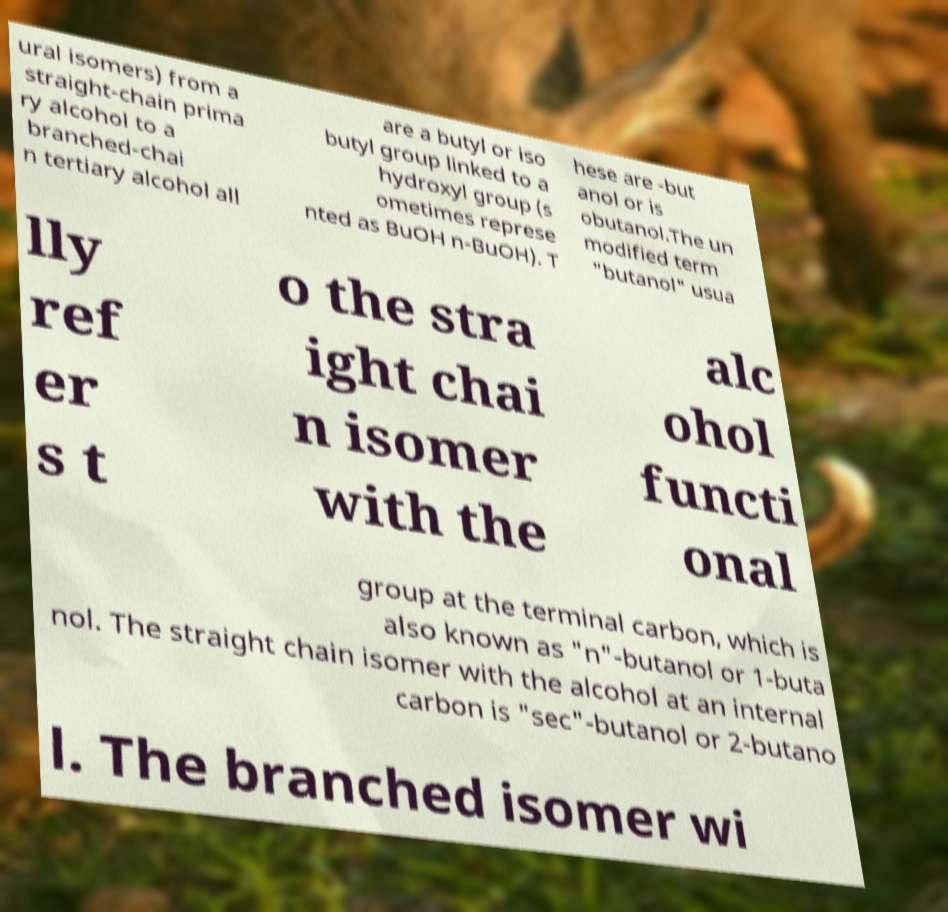Can you accurately transcribe the text from the provided image for me? ural isomers) from a straight-chain prima ry alcohol to a branched-chai n tertiary alcohol all are a butyl or iso butyl group linked to a hydroxyl group (s ometimes represe nted as BuOH n-BuOH). T hese are -but anol or is obutanol.The un modified term "butanol" usua lly ref er s t o the stra ight chai n isomer with the alc ohol functi onal group at the terminal carbon, which is also known as "n"-butanol or 1-buta nol. The straight chain isomer with the alcohol at an internal carbon is "sec"-butanol or 2-butano l. The branched isomer wi 